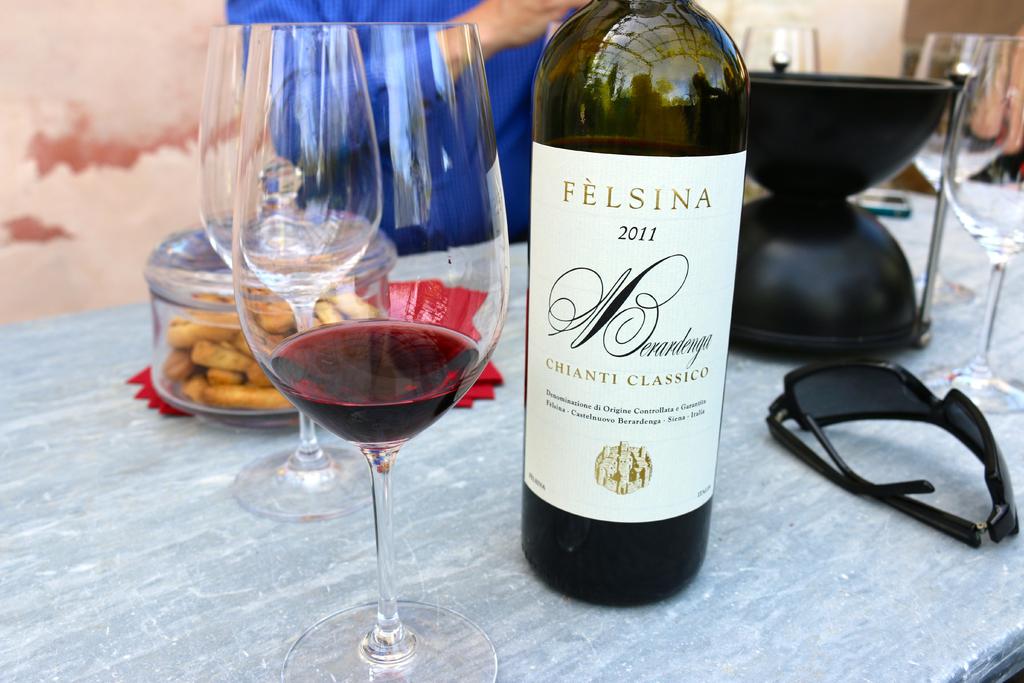What is the name of the wine?
Ensure brevity in your answer.  Felsina. What is the date on the wine/?
Offer a terse response. 2011. 